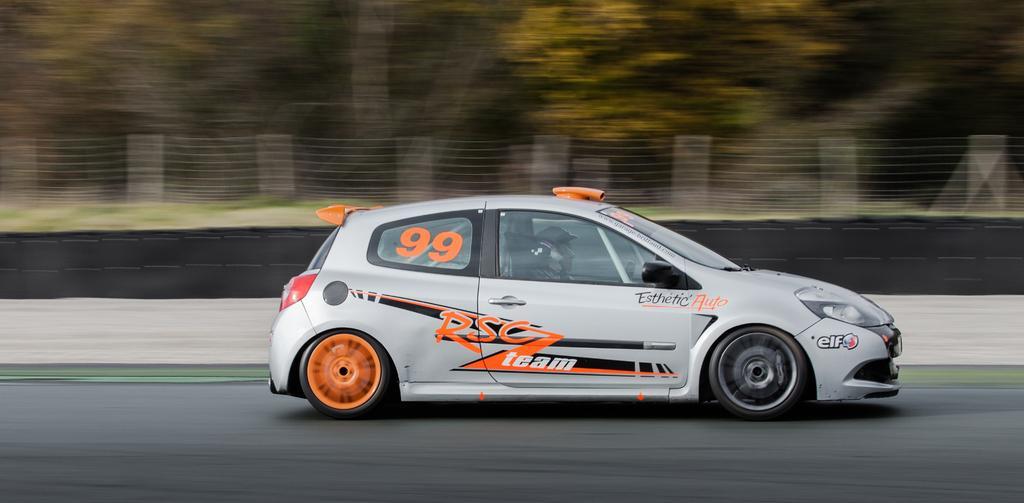In one or two sentences, can you explain what this image depicts? In this picture there are two persons who are wearing helmet and sitting inside the car. At the bottom I can see the road. In the background I can see the fencing, trees and grass. 